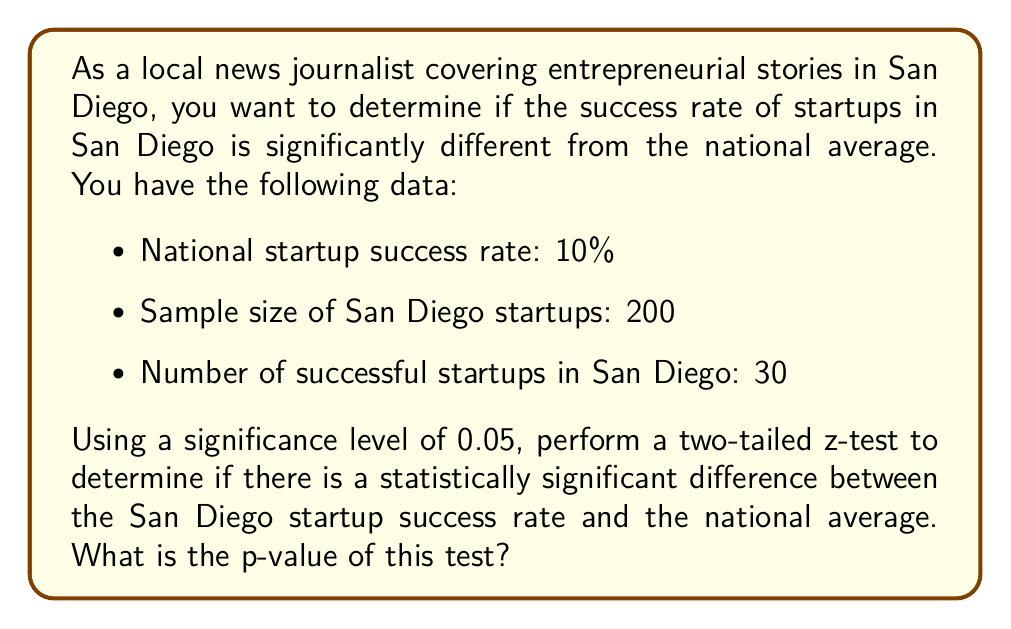Solve this math problem. To solve this problem, we'll follow these steps:

1. Define the null and alternative hypotheses
2. Calculate the sample proportion
3. Calculate the standard error
4. Calculate the z-score
5. Determine the p-value

Step 1: Define the hypotheses
Null hypothesis ($H_0$): The San Diego startup success rate is equal to the national average (10%)
Alternative hypothesis ($H_a$): The San Diego startup success rate is different from the national average

Step 2: Calculate the sample proportion
Sample proportion ($\hat{p}$) = Number of successful startups / Sample size
$$\hat{p} = \frac{30}{200} = 0.15$$

Step 3: Calculate the standard error
The standard error (SE) for a proportion is given by:
$$SE = \sqrt{\frac{p_0(1-p_0)}{n}}$$
Where $p_0$ is the hypothesized proportion (national average) and $n$ is the sample size.

$$SE = \sqrt{\frac{0.10(1-0.10)}{200}} = \sqrt{\frac{0.09}{200}} = 0.0212$$

Step 4: Calculate the z-score
The z-score is calculated using:
$$z = \frac{\hat{p} - p_0}{SE}$$

$$z = \frac{0.15 - 0.10}{0.0212} = 2.358$$

Step 5: Determine the p-value
For a two-tailed test, we need to find the area under both tails of the standard normal distribution beyond our z-score.

Using a standard normal distribution table or calculator, we find:
P(Z > 2.358) = 0.00918

For a two-tailed test, we double this value:
p-value = 2 * 0.00918 = 0.01836
Answer: The p-value of the two-tailed z-test is approximately 0.01836. 